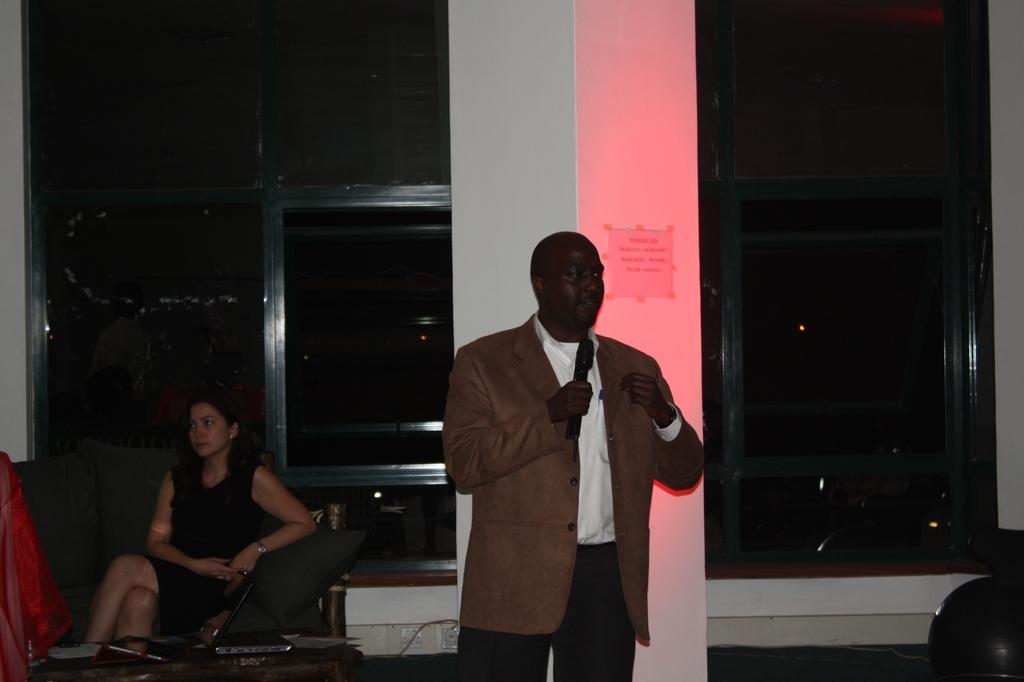Please provide a concise description of this image. There is a man talking on mic, beside him there is a woman sat on sofa at background there is red light , on whole background its dark. 